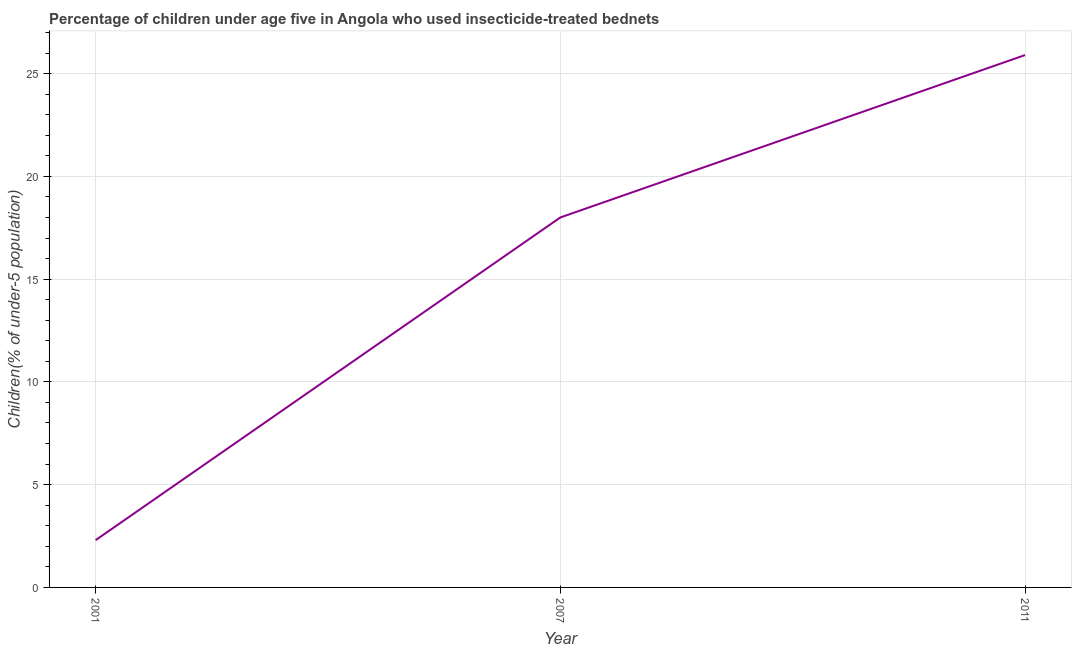Across all years, what is the maximum percentage of children who use of insecticide-treated bed nets?
Your answer should be compact. 25.9. Across all years, what is the minimum percentage of children who use of insecticide-treated bed nets?
Your response must be concise. 2.3. What is the sum of the percentage of children who use of insecticide-treated bed nets?
Make the answer very short. 46.2. What is the difference between the percentage of children who use of insecticide-treated bed nets in 2007 and 2011?
Provide a succinct answer. -7.9. What is the average percentage of children who use of insecticide-treated bed nets per year?
Keep it short and to the point. 15.4. What is the median percentage of children who use of insecticide-treated bed nets?
Make the answer very short. 18. In how many years, is the percentage of children who use of insecticide-treated bed nets greater than 19 %?
Your answer should be compact. 1. Do a majority of the years between 2001 and 2011 (inclusive) have percentage of children who use of insecticide-treated bed nets greater than 10 %?
Provide a succinct answer. Yes. What is the ratio of the percentage of children who use of insecticide-treated bed nets in 2001 to that in 2011?
Your answer should be compact. 0.09. Is the percentage of children who use of insecticide-treated bed nets in 2001 less than that in 2007?
Ensure brevity in your answer.  Yes. Is the difference between the percentage of children who use of insecticide-treated bed nets in 2007 and 2011 greater than the difference between any two years?
Offer a very short reply. No. What is the difference between the highest and the second highest percentage of children who use of insecticide-treated bed nets?
Keep it short and to the point. 7.9. Is the sum of the percentage of children who use of insecticide-treated bed nets in 2001 and 2007 greater than the maximum percentage of children who use of insecticide-treated bed nets across all years?
Provide a short and direct response. No. What is the difference between the highest and the lowest percentage of children who use of insecticide-treated bed nets?
Keep it short and to the point. 23.6. Does the percentage of children who use of insecticide-treated bed nets monotonically increase over the years?
Your response must be concise. Yes. How many lines are there?
Your response must be concise. 1. How many years are there in the graph?
Keep it short and to the point. 3. Are the values on the major ticks of Y-axis written in scientific E-notation?
Provide a short and direct response. No. Does the graph contain grids?
Keep it short and to the point. Yes. What is the title of the graph?
Provide a succinct answer. Percentage of children under age five in Angola who used insecticide-treated bednets. What is the label or title of the X-axis?
Ensure brevity in your answer.  Year. What is the label or title of the Y-axis?
Ensure brevity in your answer.  Children(% of under-5 population). What is the Children(% of under-5 population) of 2001?
Ensure brevity in your answer.  2.3. What is the Children(% of under-5 population) of 2011?
Offer a terse response. 25.9. What is the difference between the Children(% of under-5 population) in 2001 and 2007?
Give a very brief answer. -15.7. What is the difference between the Children(% of under-5 population) in 2001 and 2011?
Make the answer very short. -23.6. What is the difference between the Children(% of under-5 population) in 2007 and 2011?
Provide a succinct answer. -7.9. What is the ratio of the Children(% of under-5 population) in 2001 to that in 2007?
Give a very brief answer. 0.13. What is the ratio of the Children(% of under-5 population) in 2001 to that in 2011?
Your response must be concise. 0.09. What is the ratio of the Children(% of under-5 population) in 2007 to that in 2011?
Your answer should be very brief. 0.69. 